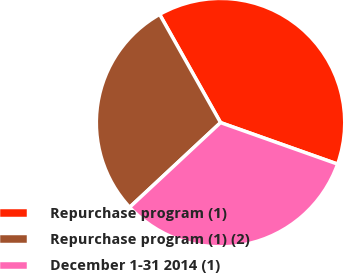Convert chart to OTSL. <chart><loc_0><loc_0><loc_500><loc_500><pie_chart><fcel>Repurchase program (1)<fcel>Repurchase program (1) (2)<fcel>December 1-31 2014 (1)<nl><fcel>38.58%<fcel>28.78%<fcel>32.64%<nl></chart> 